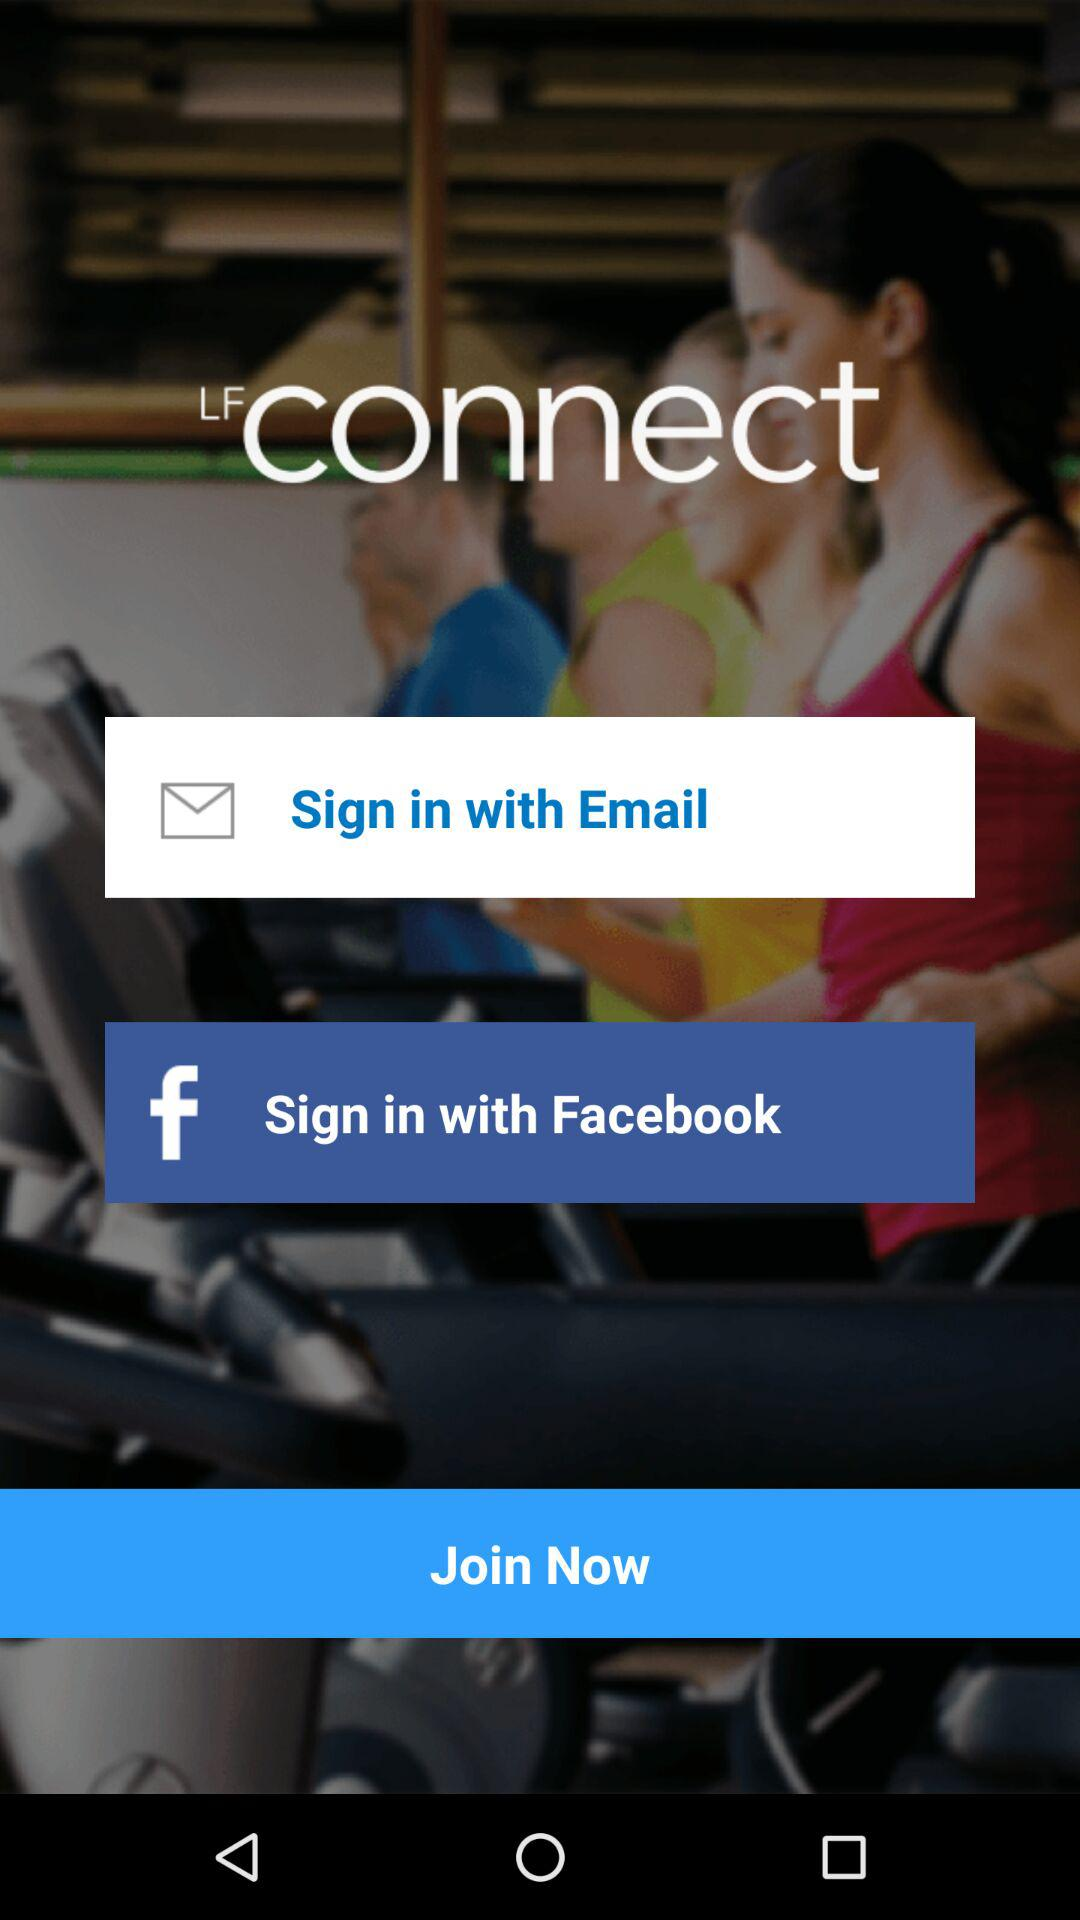What applications are used for sign in? The applications are "Email" and "Facebook". 